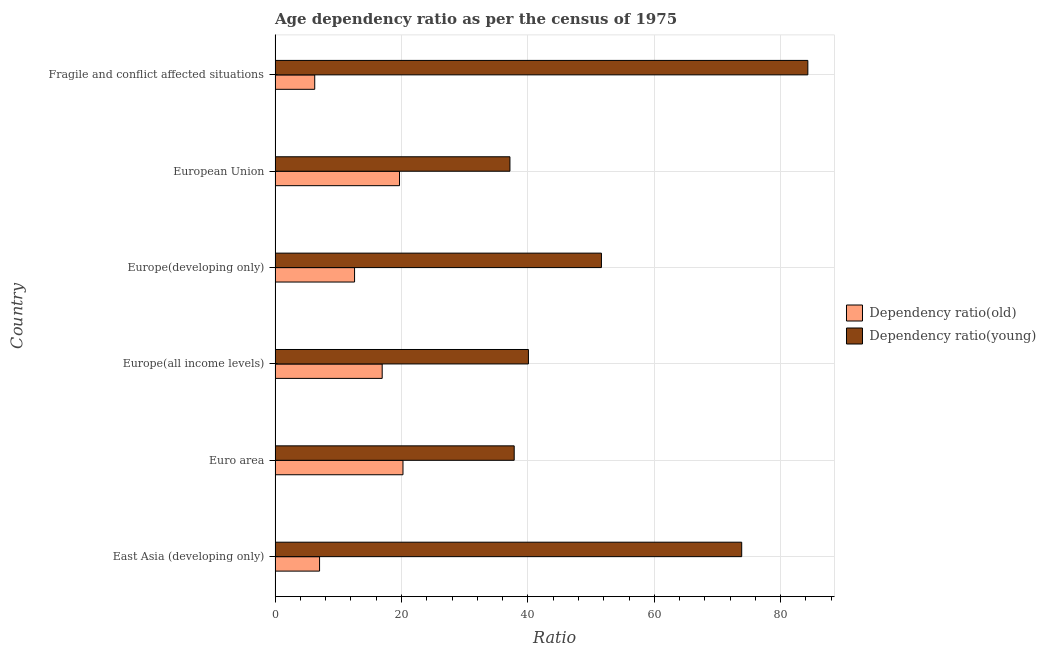How many different coloured bars are there?
Your answer should be very brief. 2. Are the number of bars per tick equal to the number of legend labels?
Your answer should be compact. Yes. How many bars are there on the 5th tick from the bottom?
Offer a terse response. 2. What is the label of the 6th group of bars from the top?
Your answer should be very brief. East Asia (developing only). In how many cases, is the number of bars for a given country not equal to the number of legend labels?
Keep it short and to the point. 0. What is the age dependency ratio(old) in Fragile and conflict affected situations?
Make the answer very short. 6.27. Across all countries, what is the maximum age dependency ratio(old)?
Your response must be concise. 20.24. Across all countries, what is the minimum age dependency ratio(young)?
Offer a terse response. 37.16. In which country was the age dependency ratio(young) maximum?
Keep it short and to the point. Fragile and conflict affected situations. What is the total age dependency ratio(young) in the graph?
Make the answer very short. 324.83. What is the difference between the age dependency ratio(old) in Europe(all income levels) and that in European Union?
Provide a succinct answer. -2.74. What is the difference between the age dependency ratio(young) in Europe(all income levels) and the age dependency ratio(old) in Euro area?
Your answer should be very brief. 19.84. What is the average age dependency ratio(young) per country?
Your response must be concise. 54.14. What is the difference between the age dependency ratio(old) and age dependency ratio(young) in Europe(developing only)?
Offer a terse response. -39.06. What is the ratio of the age dependency ratio(old) in East Asia (developing only) to that in Europe(all income levels)?
Provide a short and direct response. 0.41. Is the age dependency ratio(young) in Europe(developing only) less than that in Fragile and conflict affected situations?
Provide a succinct answer. Yes. What is the difference between the highest and the second highest age dependency ratio(old)?
Make the answer very short. 0.55. What is the difference between the highest and the lowest age dependency ratio(old)?
Provide a succinct answer. 13.96. In how many countries, is the age dependency ratio(young) greater than the average age dependency ratio(young) taken over all countries?
Provide a short and direct response. 2. Is the sum of the age dependency ratio(young) in Euro area and European Union greater than the maximum age dependency ratio(old) across all countries?
Provide a short and direct response. Yes. What does the 2nd bar from the top in Europe(developing only) represents?
Give a very brief answer. Dependency ratio(old). What does the 1st bar from the bottom in Euro area represents?
Keep it short and to the point. Dependency ratio(old). How many bars are there?
Provide a short and direct response. 12. How many countries are there in the graph?
Provide a succinct answer. 6. Are the values on the major ticks of X-axis written in scientific E-notation?
Make the answer very short. No. Does the graph contain any zero values?
Offer a terse response. No. Where does the legend appear in the graph?
Provide a short and direct response. Center right. How are the legend labels stacked?
Offer a terse response. Vertical. What is the title of the graph?
Make the answer very short. Age dependency ratio as per the census of 1975. What is the label or title of the X-axis?
Offer a terse response. Ratio. What is the Ratio of Dependency ratio(old) in East Asia (developing only)?
Your answer should be compact. 7.04. What is the Ratio in Dependency ratio(young) in East Asia (developing only)?
Offer a very short reply. 73.83. What is the Ratio of Dependency ratio(old) in Euro area?
Give a very brief answer. 20.24. What is the Ratio of Dependency ratio(young) in Euro area?
Your answer should be very brief. 37.83. What is the Ratio of Dependency ratio(old) in Europe(all income levels)?
Your response must be concise. 16.95. What is the Ratio in Dependency ratio(young) in Europe(all income levels)?
Offer a terse response. 40.08. What is the Ratio of Dependency ratio(old) in Europe(developing only)?
Give a very brief answer. 12.58. What is the Ratio in Dependency ratio(young) in Europe(developing only)?
Make the answer very short. 51.63. What is the Ratio of Dependency ratio(old) in European Union?
Keep it short and to the point. 19.69. What is the Ratio in Dependency ratio(young) in European Union?
Your answer should be compact. 37.16. What is the Ratio in Dependency ratio(old) in Fragile and conflict affected situations?
Keep it short and to the point. 6.27. What is the Ratio in Dependency ratio(young) in Fragile and conflict affected situations?
Keep it short and to the point. 84.29. Across all countries, what is the maximum Ratio in Dependency ratio(old)?
Your answer should be compact. 20.24. Across all countries, what is the maximum Ratio in Dependency ratio(young)?
Give a very brief answer. 84.29. Across all countries, what is the minimum Ratio of Dependency ratio(old)?
Keep it short and to the point. 6.27. Across all countries, what is the minimum Ratio of Dependency ratio(young)?
Offer a terse response. 37.16. What is the total Ratio in Dependency ratio(old) in the graph?
Your answer should be very brief. 82.76. What is the total Ratio of Dependency ratio(young) in the graph?
Keep it short and to the point. 324.83. What is the difference between the Ratio in Dependency ratio(old) in East Asia (developing only) and that in Euro area?
Your response must be concise. -13.2. What is the difference between the Ratio of Dependency ratio(young) in East Asia (developing only) and that in Euro area?
Provide a succinct answer. 36. What is the difference between the Ratio of Dependency ratio(old) in East Asia (developing only) and that in Europe(all income levels)?
Offer a terse response. -9.91. What is the difference between the Ratio in Dependency ratio(young) in East Asia (developing only) and that in Europe(all income levels)?
Offer a terse response. 33.75. What is the difference between the Ratio of Dependency ratio(old) in East Asia (developing only) and that in Europe(developing only)?
Offer a very short reply. -5.54. What is the difference between the Ratio of Dependency ratio(young) in East Asia (developing only) and that in Europe(developing only)?
Provide a short and direct response. 22.19. What is the difference between the Ratio in Dependency ratio(old) in East Asia (developing only) and that in European Union?
Your answer should be very brief. -12.65. What is the difference between the Ratio in Dependency ratio(young) in East Asia (developing only) and that in European Union?
Your answer should be compact. 36.67. What is the difference between the Ratio of Dependency ratio(old) in East Asia (developing only) and that in Fragile and conflict affected situations?
Ensure brevity in your answer.  0.76. What is the difference between the Ratio in Dependency ratio(young) in East Asia (developing only) and that in Fragile and conflict affected situations?
Ensure brevity in your answer.  -10.46. What is the difference between the Ratio in Dependency ratio(old) in Euro area and that in Europe(all income levels)?
Your answer should be very brief. 3.29. What is the difference between the Ratio in Dependency ratio(young) in Euro area and that in Europe(all income levels)?
Your response must be concise. -2.25. What is the difference between the Ratio of Dependency ratio(old) in Euro area and that in Europe(developing only)?
Your answer should be very brief. 7.66. What is the difference between the Ratio in Dependency ratio(young) in Euro area and that in Europe(developing only)?
Give a very brief answer. -13.8. What is the difference between the Ratio in Dependency ratio(old) in Euro area and that in European Union?
Keep it short and to the point. 0.55. What is the difference between the Ratio in Dependency ratio(young) in Euro area and that in European Union?
Give a very brief answer. 0.67. What is the difference between the Ratio of Dependency ratio(old) in Euro area and that in Fragile and conflict affected situations?
Your response must be concise. 13.96. What is the difference between the Ratio in Dependency ratio(young) in Euro area and that in Fragile and conflict affected situations?
Give a very brief answer. -46.46. What is the difference between the Ratio in Dependency ratio(old) in Europe(all income levels) and that in Europe(developing only)?
Offer a terse response. 4.37. What is the difference between the Ratio of Dependency ratio(young) in Europe(all income levels) and that in Europe(developing only)?
Offer a very short reply. -11.55. What is the difference between the Ratio of Dependency ratio(old) in Europe(all income levels) and that in European Union?
Give a very brief answer. -2.74. What is the difference between the Ratio in Dependency ratio(young) in Europe(all income levels) and that in European Union?
Your response must be concise. 2.92. What is the difference between the Ratio in Dependency ratio(old) in Europe(all income levels) and that in Fragile and conflict affected situations?
Your answer should be very brief. 10.67. What is the difference between the Ratio in Dependency ratio(young) in Europe(all income levels) and that in Fragile and conflict affected situations?
Your answer should be compact. -44.21. What is the difference between the Ratio in Dependency ratio(old) in Europe(developing only) and that in European Union?
Give a very brief answer. -7.11. What is the difference between the Ratio in Dependency ratio(young) in Europe(developing only) and that in European Union?
Give a very brief answer. 14.48. What is the difference between the Ratio in Dependency ratio(old) in Europe(developing only) and that in Fragile and conflict affected situations?
Offer a very short reply. 6.3. What is the difference between the Ratio in Dependency ratio(young) in Europe(developing only) and that in Fragile and conflict affected situations?
Offer a terse response. -32.66. What is the difference between the Ratio in Dependency ratio(old) in European Union and that in Fragile and conflict affected situations?
Make the answer very short. 13.41. What is the difference between the Ratio in Dependency ratio(young) in European Union and that in Fragile and conflict affected situations?
Provide a short and direct response. -47.13. What is the difference between the Ratio in Dependency ratio(old) in East Asia (developing only) and the Ratio in Dependency ratio(young) in Euro area?
Your answer should be compact. -30.79. What is the difference between the Ratio of Dependency ratio(old) in East Asia (developing only) and the Ratio of Dependency ratio(young) in Europe(all income levels)?
Offer a very short reply. -33.04. What is the difference between the Ratio of Dependency ratio(old) in East Asia (developing only) and the Ratio of Dependency ratio(young) in Europe(developing only)?
Make the answer very short. -44.6. What is the difference between the Ratio of Dependency ratio(old) in East Asia (developing only) and the Ratio of Dependency ratio(young) in European Union?
Give a very brief answer. -30.12. What is the difference between the Ratio in Dependency ratio(old) in East Asia (developing only) and the Ratio in Dependency ratio(young) in Fragile and conflict affected situations?
Provide a short and direct response. -77.25. What is the difference between the Ratio of Dependency ratio(old) in Euro area and the Ratio of Dependency ratio(young) in Europe(all income levels)?
Your response must be concise. -19.84. What is the difference between the Ratio in Dependency ratio(old) in Euro area and the Ratio in Dependency ratio(young) in Europe(developing only)?
Your answer should be very brief. -31.4. What is the difference between the Ratio in Dependency ratio(old) in Euro area and the Ratio in Dependency ratio(young) in European Union?
Provide a short and direct response. -16.92. What is the difference between the Ratio of Dependency ratio(old) in Euro area and the Ratio of Dependency ratio(young) in Fragile and conflict affected situations?
Provide a short and direct response. -64.05. What is the difference between the Ratio of Dependency ratio(old) in Europe(all income levels) and the Ratio of Dependency ratio(young) in Europe(developing only)?
Ensure brevity in your answer.  -34.69. What is the difference between the Ratio of Dependency ratio(old) in Europe(all income levels) and the Ratio of Dependency ratio(young) in European Union?
Give a very brief answer. -20.21. What is the difference between the Ratio in Dependency ratio(old) in Europe(all income levels) and the Ratio in Dependency ratio(young) in Fragile and conflict affected situations?
Keep it short and to the point. -67.35. What is the difference between the Ratio in Dependency ratio(old) in Europe(developing only) and the Ratio in Dependency ratio(young) in European Union?
Your answer should be very brief. -24.58. What is the difference between the Ratio of Dependency ratio(old) in Europe(developing only) and the Ratio of Dependency ratio(young) in Fragile and conflict affected situations?
Your answer should be very brief. -71.72. What is the difference between the Ratio in Dependency ratio(old) in European Union and the Ratio in Dependency ratio(young) in Fragile and conflict affected situations?
Give a very brief answer. -64.6. What is the average Ratio of Dependency ratio(old) per country?
Your response must be concise. 13.79. What is the average Ratio in Dependency ratio(young) per country?
Make the answer very short. 54.14. What is the difference between the Ratio of Dependency ratio(old) and Ratio of Dependency ratio(young) in East Asia (developing only)?
Make the answer very short. -66.79. What is the difference between the Ratio of Dependency ratio(old) and Ratio of Dependency ratio(young) in Euro area?
Ensure brevity in your answer.  -17.59. What is the difference between the Ratio of Dependency ratio(old) and Ratio of Dependency ratio(young) in Europe(all income levels)?
Keep it short and to the point. -23.14. What is the difference between the Ratio of Dependency ratio(old) and Ratio of Dependency ratio(young) in Europe(developing only)?
Offer a terse response. -39.06. What is the difference between the Ratio in Dependency ratio(old) and Ratio in Dependency ratio(young) in European Union?
Offer a very short reply. -17.47. What is the difference between the Ratio in Dependency ratio(old) and Ratio in Dependency ratio(young) in Fragile and conflict affected situations?
Keep it short and to the point. -78.02. What is the ratio of the Ratio of Dependency ratio(old) in East Asia (developing only) to that in Euro area?
Offer a terse response. 0.35. What is the ratio of the Ratio in Dependency ratio(young) in East Asia (developing only) to that in Euro area?
Your response must be concise. 1.95. What is the ratio of the Ratio in Dependency ratio(old) in East Asia (developing only) to that in Europe(all income levels)?
Give a very brief answer. 0.42. What is the ratio of the Ratio in Dependency ratio(young) in East Asia (developing only) to that in Europe(all income levels)?
Provide a succinct answer. 1.84. What is the ratio of the Ratio of Dependency ratio(old) in East Asia (developing only) to that in Europe(developing only)?
Give a very brief answer. 0.56. What is the ratio of the Ratio of Dependency ratio(young) in East Asia (developing only) to that in Europe(developing only)?
Your answer should be compact. 1.43. What is the ratio of the Ratio in Dependency ratio(old) in East Asia (developing only) to that in European Union?
Provide a succinct answer. 0.36. What is the ratio of the Ratio in Dependency ratio(young) in East Asia (developing only) to that in European Union?
Your answer should be very brief. 1.99. What is the ratio of the Ratio of Dependency ratio(old) in East Asia (developing only) to that in Fragile and conflict affected situations?
Offer a terse response. 1.12. What is the ratio of the Ratio of Dependency ratio(young) in East Asia (developing only) to that in Fragile and conflict affected situations?
Provide a short and direct response. 0.88. What is the ratio of the Ratio in Dependency ratio(old) in Euro area to that in Europe(all income levels)?
Offer a very short reply. 1.19. What is the ratio of the Ratio of Dependency ratio(young) in Euro area to that in Europe(all income levels)?
Your response must be concise. 0.94. What is the ratio of the Ratio of Dependency ratio(old) in Euro area to that in Europe(developing only)?
Your answer should be very brief. 1.61. What is the ratio of the Ratio of Dependency ratio(young) in Euro area to that in Europe(developing only)?
Provide a short and direct response. 0.73. What is the ratio of the Ratio of Dependency ratio(old) in Euro area to that in European Union?
Offer a very short reply. 1.03. What is the ratio of the Ratio in Dependency ratio(young) in Euro area to that in European Union?
Keep it short and to the point. 1.02. What is the ratio of the Ratio in Dependency ratio(old) in Euro area to that in Fragile and conflict affected situations?
Ensure brevity in your answer.  3.23. What is the ratio of the Ratio of Dependency ratio(young) in Euro area to that in Fragile and conflict affected situations?
Offer a terse response. 0.45. What is the ratio of the Ratio of Dependency ratio(old) in Europe(all income levels) to that in Europe(developing only)?
Keep it short and to the point. 1.35. What is the ratio of the Ratio of Dependency ratio(young) in Europe(all income levels) to that in Europe(developing only)?
Your response must be concise. 0.78. What is the ratio of the Ratio in Dependency ratio(old) in Europe(all income levels) to that in European Union?
Provide a short and direct response. 0.86. What is the ratio of the Ratio in Dependency ratio(young) in Europe(all income levels) to that in European Union?
Make the answer very short. 1.08. What is the ratio of the Ratio of Dependency ratio(old) in Europe(all income levels) to that in Fragile and conflict affected situations?
Ensure brevity in your answer.  2.7. What is the ratio of the Ratio in Dependency ratio(young) in Europe(all income levels) to that in Fragile and conflict affected situations?
Provide a short and direct response. 0.48. What is the ratio of the Ratio of Dependency ratio(old) in Europe(developing only) to that in European Union?
Provide a succinct answer. 0.64. What is the ratio of the Ratio of Dependency ratio(young) in Europe(developing only) to that in European Union?
Your answer should be very brief. 1.39. What is the ratio of the Ratio in Dependency ratio(old) in Europe(developing only) to that in Fragile and conflict affected situations?
Offer a very short reply. 2. What is the ratio of the Ratio of Dependency ratio(young) in Europe(developing only) to that in Fragile and conflict affected situations?
Offer a very short reply. 0.61. What is the ratio of the Ratio of Dependency ratio(old) in European Union to that in Fragile and conflict affected situations?
Your answer should be compact. 3.14. What is the ratio of the Ratio of Dependency ratio(young) in European Union to that in Fragile and conflict affected situations?
Offer a terse response. 0.44. What is the difference between the highest and the second highest Ratio of Dependency ratio(old)?
Your answer should be very brief. 0.55. What is the difference between the highest and the second highest Ratio of Dependency ratio(young)?
Offer a very short reply. 10.46. What is the difference between the highest and the lowest Ratio in Dependency ratio(old)?
Offer a terse response. 13.96. What is the difference between the highest and the lowest Ratio of Dependency ratio(young)?
Offer a very short reply. 47.13. 